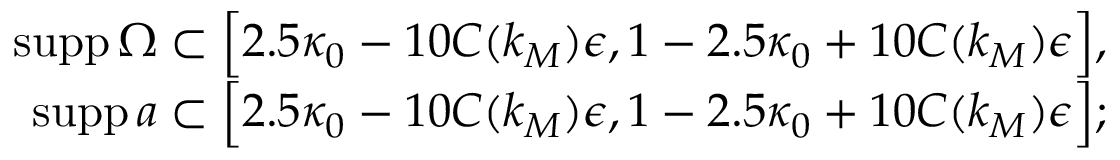<formula> <loc_0><loc_0><loc_500><loc_500>\begin{array} { r } { s u p p \, \Omega \subset \left [ 2 . 5 \kappa _ { 0 } - 1 0 C ( k _ { M } ) \epsilon , 1 - 2 . 5 \kappa _ { 0 } + 1 0 C ( k _ { M } ) \epsilon \right ] , } \\ { s u p p \, a \subset \left [ 2 . 5 \kappa _ { 0 } - 1 0 C ( k _ { M } ) \epsilon , 1 - 2 . 5 \kappa _ { 0 } + 1 0 C ( k _ { M } ) \epsilon \right ] ; } \end{array}</formula> 